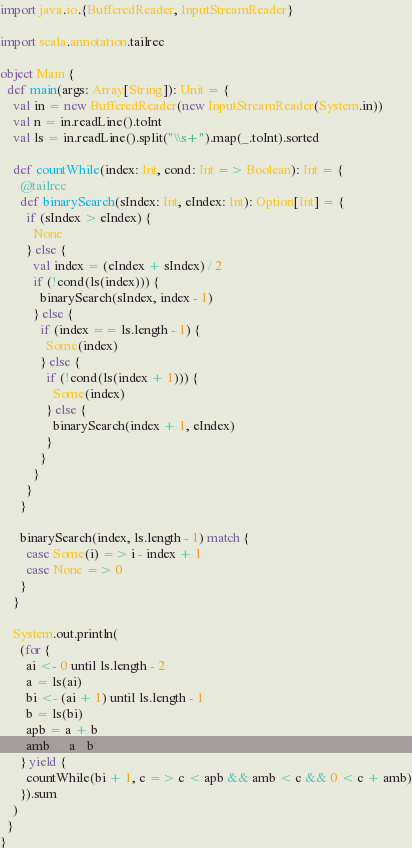Convert code to text. <code><loc_0><loc_0><loc_500><loc_500><_Scala_>import java.io.{BufferedReader, InputStreamReader}

import scala.annotation.tailrec

object Main {
  def main(args: Array[String]): Unit = {
    val in = new BufferedReader(new InputStreamReader(System.in))
    val n = in.readLine().toInt
    val ls = in.readLine().split("\\s+").map(_.toInt).sorted

    def countWhile(index: Int, cond: Int => Boolean): Int = {
      @tailrec
      def binarySearch(sIndex: Int, eIndex: Int): Option[Int] = {
        if (sIndex > eIndex) {
          None
        } else {
          val index = (eIndex + sIndex) / 2
          if (!cond(ls(index))) {
            binarySearch(sIndex, index - 1)
          } else {
            if (index == ls.length - 1) {
              Some(index)
            } else {
              if (!cond(ls(index + 1))) {
                Some(index)
              } else {
                binarySearch(index + 1, eIndex)
              }
            }
          }
        }
      }

      binarySearch(index, ls.length - 1) match {
        case Some(i) => i - index + 1
        case None => 0
      }
    }

    System.out.println(
      (for {
        ai <- 0 until ls.length - 2
        a = ls(ai)
        bi <- (ai + 1) until ls.length - 1
        b = ls(bi)
        apb = a + b
        amb = a - b
      } yield {
        countWhile(bi + 1, c => c < apb && amb < c && 0 < c + amb)
      }).sum
    )
  }
}
</code> 